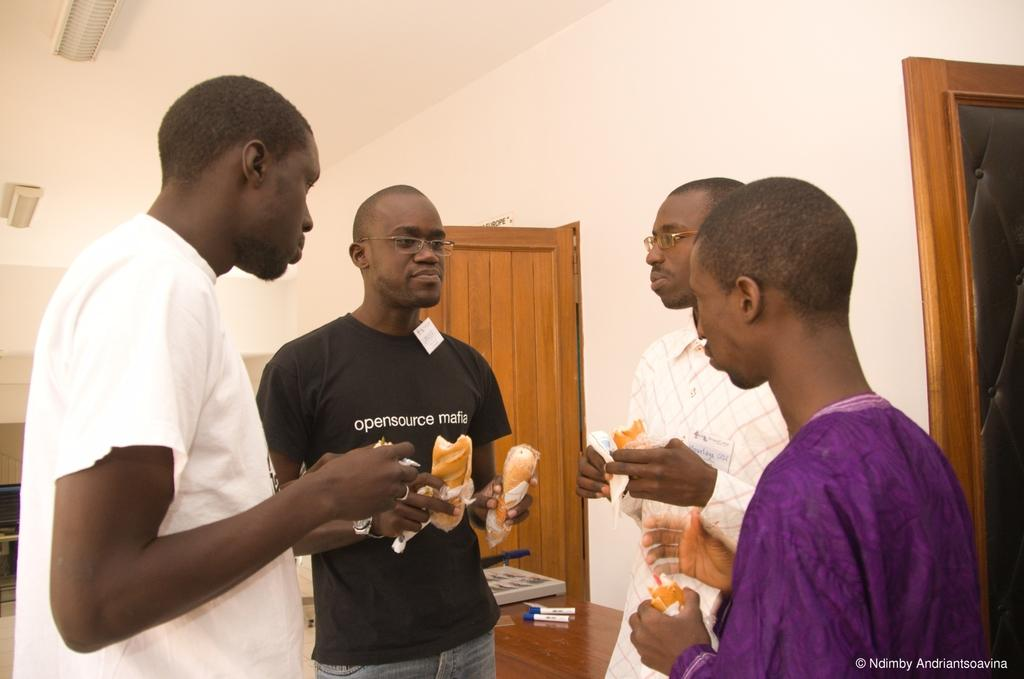How many people are in the image? There are people in the image, but the exact number is not specified. What are the people holding in the image? The people are holding food in the image. What can be seen in the background of the image? In the background of the image, there is a table, sketch pens, a wall, a roof, tube lights, a door, and some objects. Can you describe the lighting in the image? The lighting in the image is provided by tube lights, which are visible in the background. What might be the purpose of the door in the background? The door in the background could be used for entering or exiting the room or space where the image was taken. What type of needle is being used to sew the territory in the image? There is no needle or territory present in the image. 